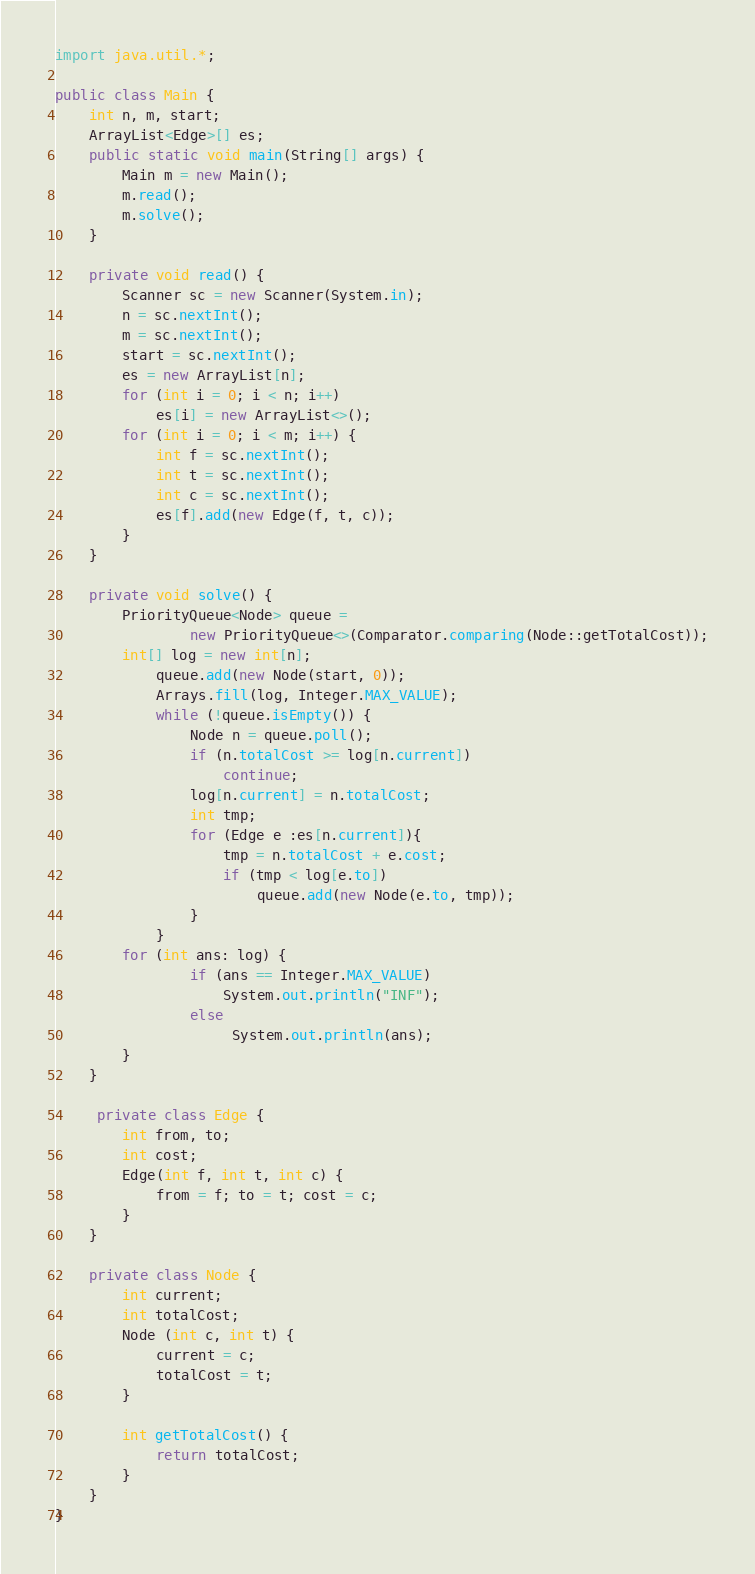Convert code to text. <code><loc_0><loc_0><loc_500><loc_500><_Java_>
import java.util.*;

public class Main {
    int n, m, start;
    ArrayList<Edge>[] es;
    public static void main(String[] args) {
        Main m = new Main();
        m.read();
        m.solve();
    }

    private void read() {
        Scanner sc = new Scanner(System.in);
        n = sc.nextInt();
        m = sc.nextInt();
        start = sc.nextInt();
        es = new ArrayList[n];
        for (int i = 0; i < n; i++)
            es[i] = new ArrayList<>();
        for (int i = 0; i < m; i++) {
            int f = sc.nextInt();
            int t = sc.nextInt();
            int c = sc.nextInt();
            es[f].add(new Edge(f, t, c));
        }
    }

    private void solve() {
        PriorityQueue<Node> queue =
                new PriorityQueue<>(Comparator.comparing(Node::getTotalCost));
        int[] log = new int[n];
            queue.add(new Node(start, 0));
            Arrays.fill(log, Integer.MAX_VALUE);
            while (!queue.isEmpty()) {
                Node n = queue.poll();
                if (n.totalCost >= log[n.current])
                    continue;
                log[n.current] = n.totalCost;
                int tmp;
                for (Edge e :es[n.current]){
                    tmp = n.totalCost + e.cost;
                    if (tmp < log[e.to])
                        queue.add(new Node(e.to, tmp));
                }
            }
        for (int ans: log) {
                if (ans == Integer.MAX_VALUE)
                    System.out.println("INF");
                else
                     System.out.println(ans);
        }
    }

     private class Edge {
        int from, to;
        int cost;
        Edge(int f, int t, int c) {
            from = f; to = t; cost = c;
        }
    }

    private class Node {
        int current;
        int totalCost;
        Node (int c, int t) {
            current = c;
            totalCost = t;
        }

        int getTotalCost() {
            return totalCost;
        }
    }
}</code> 